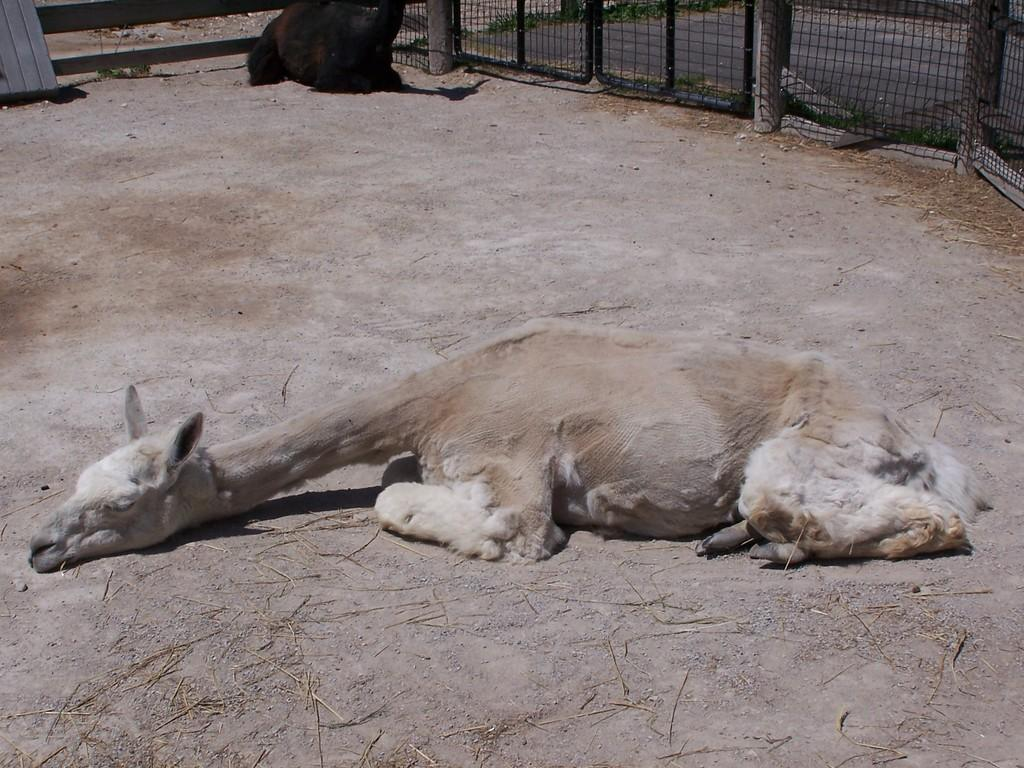What is the main subject of the image? There is an animal lying on the ground in the image. Can you describe the secondary subject in the image? There is another animal visible in the background of the image. What can be seen in the background of the image besides the second animal? There is a fence and a road in the background of the image. Where is the loaf of bread placed on the shelf in the image? There is no loaf of bread or shelf present in the image. 